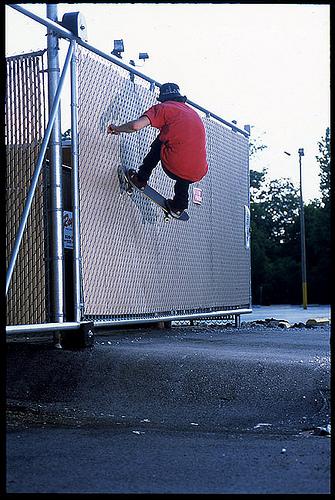What color is the person's shirt?
Short answer required. Red. What trick is this?
Concise answer only. Skateboarding. What is the fence made of?
Answer briefly. Metal. 